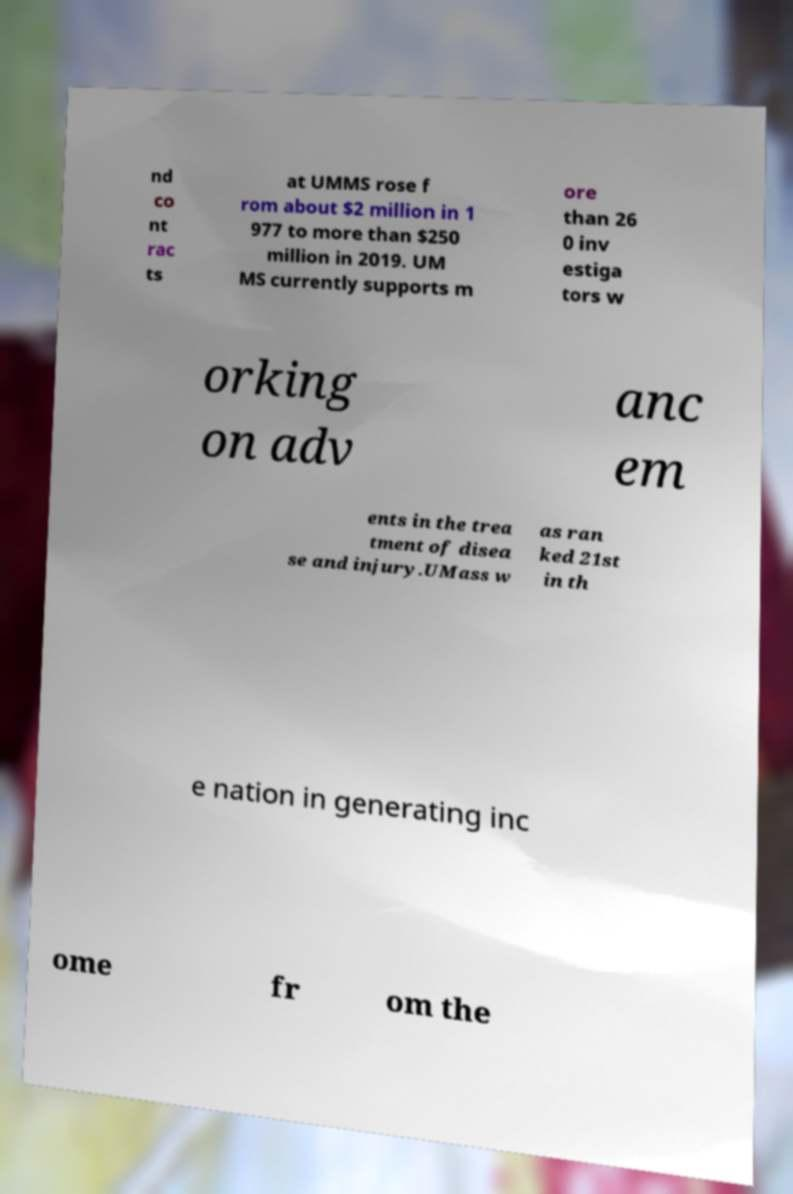Please read and relay the text visible in this image. What does it say? nd co nt rac ts at UMMS rose f rom about $2 million in 1 977 to more than $250 million in 2019. UM MS currently supports m ore than 26 0 inv estiga tors w orking on adv anc em ents in the trea tment of disea se and injury.UMass w as ran ked 21st in th e nation in generating inc ome fr om the 